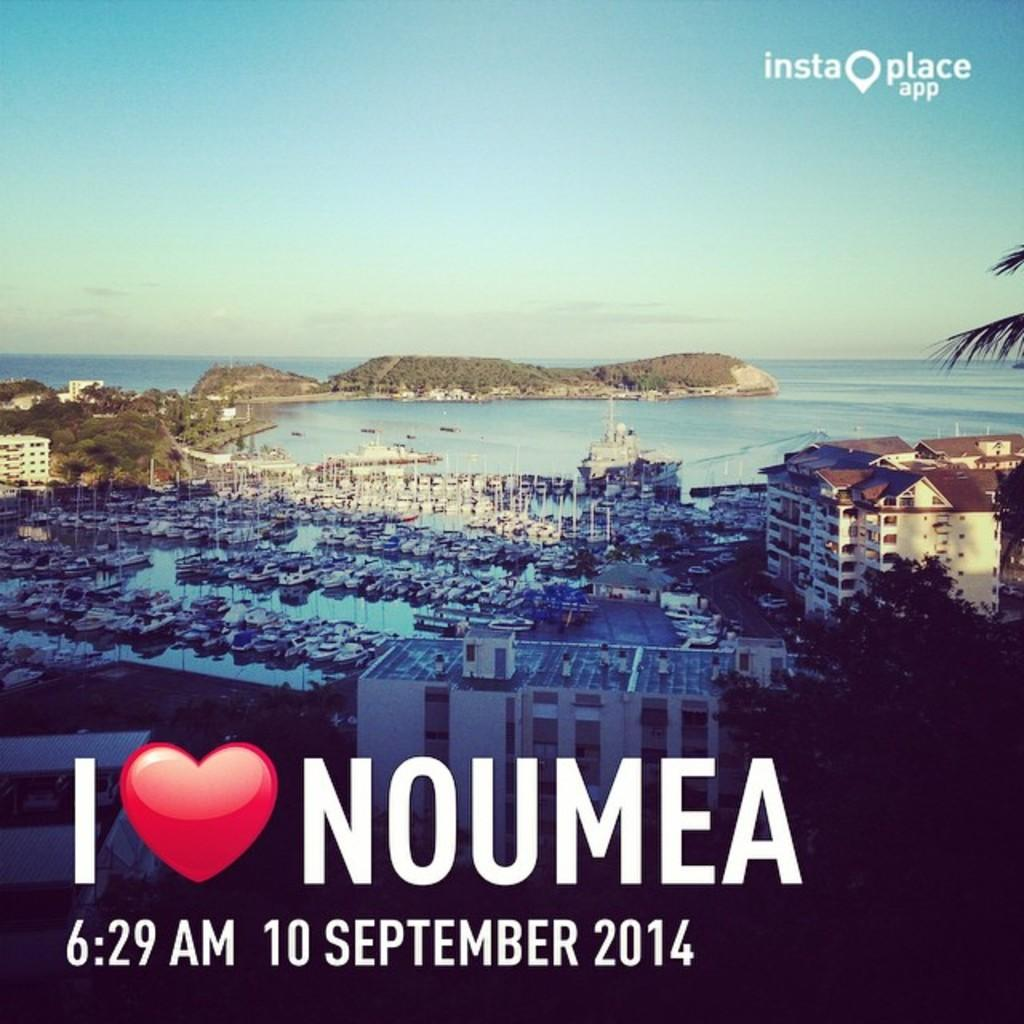<image>
Summarize the visual content of the image. poster that says i love noumea with the date of 10 of september 2014. 